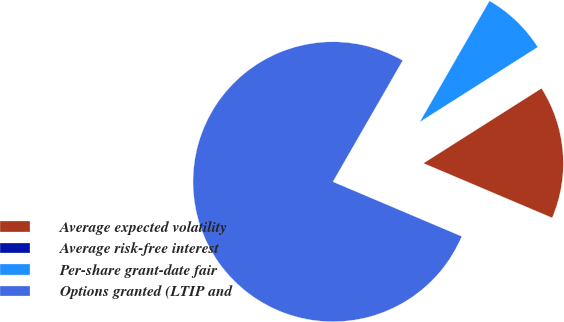<chart> <loc_0><loc_0><loc_500><loc_500><pie_chart><fcel>Average expected volatility<fcel>Average risk-free interest<fcel>Per-share grant-date fair<fcel>Options granted (LTIP and<nl><fcel>15.38%<fcel>0.0%<fcel>7.69%<fcel>76.92%<nl></chart> 